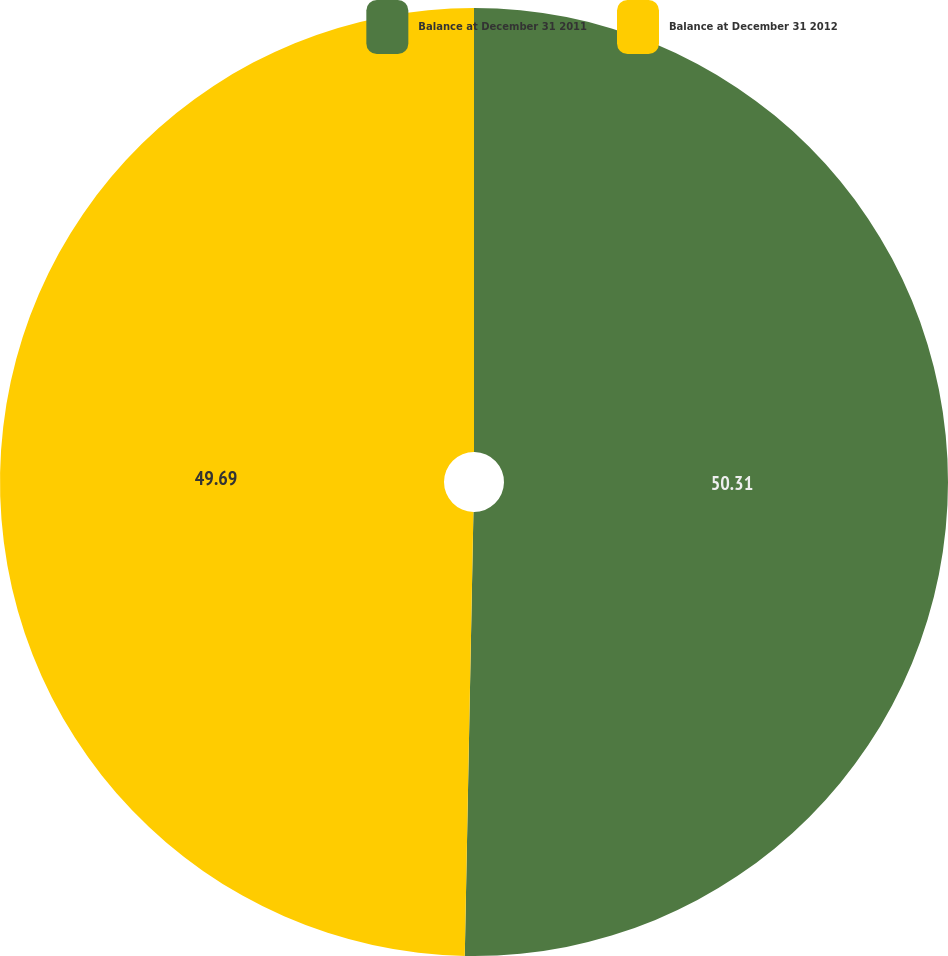Convert chart to OTSL. <chart><loc_0><loc_0><loc_500><loc_500><pie_chart><fcel>Balance at December 31 2011<fcel>Balance at December 31 2012<nl><fcel>50.31%<fcel>49.69%<nl></chart> 